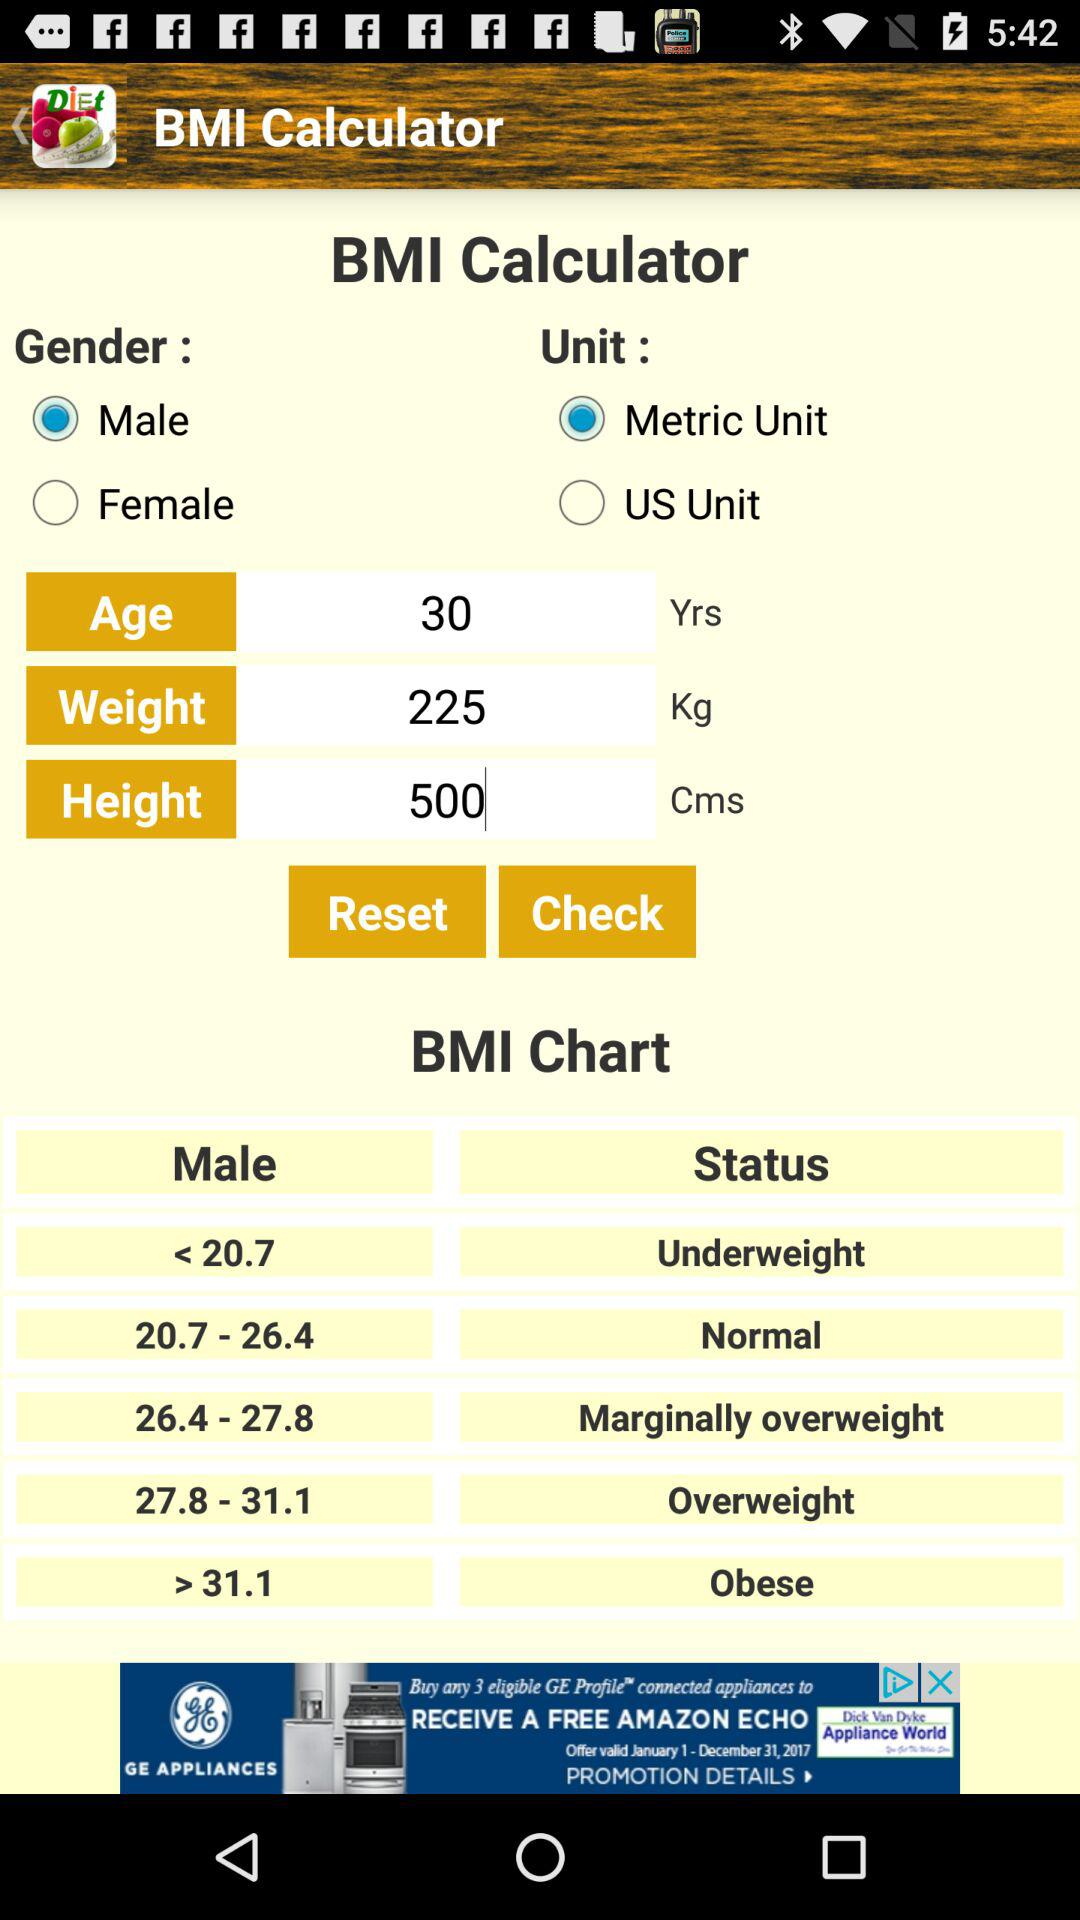What is the weight range for an overweight male? The weight limit for an overweight male is 27.8–31.1. 